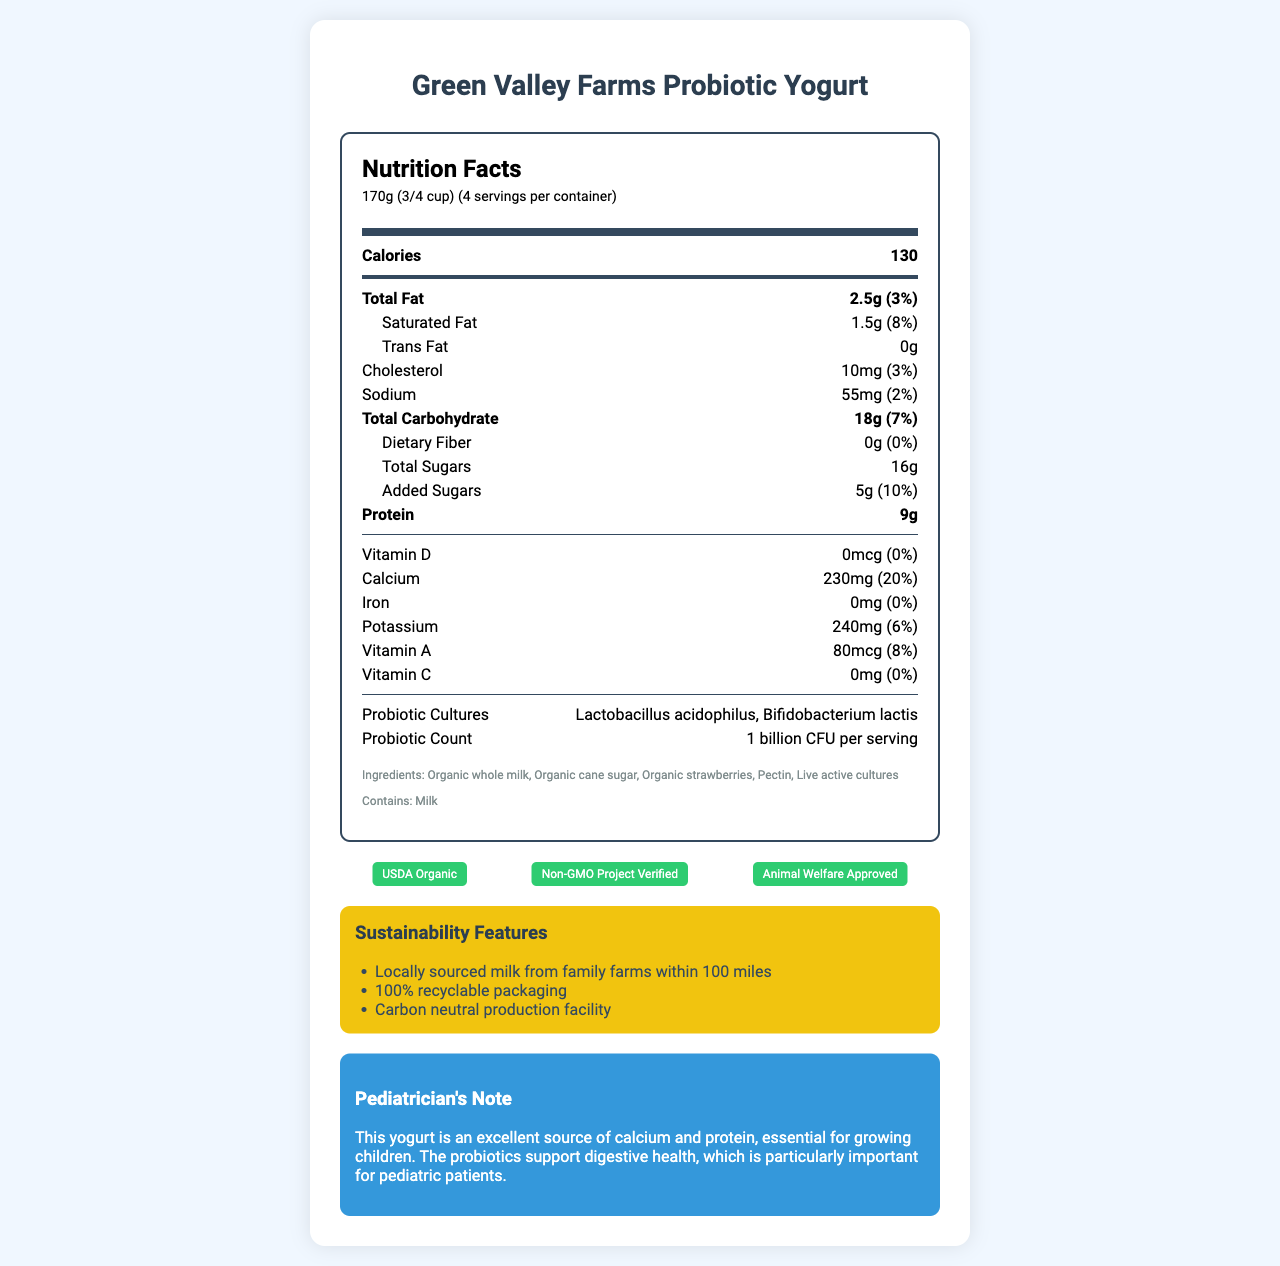who produces the yogurt? The product name mentioned at the beginning of the document is "Green Valley Farms Probiotic Yogurt," indicating the producer is Green Valley Farms.
Answer: Green Valley Farms what is the serving size for the yogurt? The document specifies the serving size as "170g (3/4 cup)" near the top under the heading "Nutrition Facts."
Answer: 170g (3/4 cup) how many servings are there per container? The document states there are "4 servings per container" in the serving information section.
Answer: 4 how many calories are in one serving? The calories per serving are listed as "130" in the bold calories section.
Answer: 130 what percentage of the daily value of calcium does this yogurt provide? The daily value for calcium is stated to be "20%" in the nutritional information section.
Answer: 20% what type of milk is used in this yogurt? The ingredients list includes "Organic whole milk" as one of the components.
Answer: Organic whole milk which probiotic cultures are present in the yogurt? A. Lactobacillus acidophilus B. Bifidobacterium longum C. Lactobacillus acidophilus and Bifidobacterium lactis D. Lactobacillus rhamnosus The document lists "Lactobacillus acidophilus, Bifidobacterium lactis" under probiotic cultures.
Answer: C what is the total fat content per serving? The total fat content is listed as "2.5g" in the nutrition information section.
Answer: 2.5g is this product non-GMO? The certifications section shows that the yogurt is "Non-GMO Project Verified," indicating it is non-GMO.
Answer: Yes how many grams of protein are in one serving? The nutritional information lists the protein content as "9g."
Answer: 9g how much added sugar is in one serving? The amount of added sugars per serving is "5g" as mentioned in the sub-item under total sugars.
Answer: 5g what is the percentage of daily value for sodium? The daily value for sodium is "2%" as listed in the nutritional information section.
Answer: 2% which certification indicates that animal welfare standards are met? A. USDA Organic B. Non-GMO Project Verified C. Animal Welfare Approved D. Whole30 Approved The document lists "Animal Welfare Approved" under the certifications, indicating animal welfare standards are met.
Answer: C does this yogurt contain any dietary fiber? The document states "Dietary Fiber: 0g (0%)" indicating it contains no dietary fiber.
Answer: No describe the sustainability features of this yogurt. The sustainability section describes that the product uses locally sourced milk, has fully recyclable packaging, and is produced in a carbon-neutral facility.
Answer: The yogurt features milk sourced locally from family farms within 100 miles, 100% recyclable packaging, and is produced in a carbon-neutral facility. how many billion CFU of probiotics are present per serving? The document lists the probiotic count as "1 billion CFU per serving" in the nutritional information section.
Answer: 1 billion what is the primary allergen listed for this yogurt? The allergens section states "Contains: Milk," indicating milk as the primary allergen.
Answer: Milk what is the daily value percentage for vitamin D in this yogurt? The document lists the daily value for vitamin D as "0%" in the nutritional information section.
Answer: 0% how much sugar does this yogurt contain in total? The document states that the yogurt contains "16g" of total sugars.
Answer: 16g are any artificial flavors mentioned in the ingredients list? The ingredients list does not mention any artificial flavors, and all listed ingredients are organic and natural components.
Answer: No what is the pediatrician's note about this yogurt? The pediatrician's note provided in the document highlights the yogurt as a good source of calcium and protein and mentions the importance of probiotics for digestive health in children.
Answer: This yogurt is an excellent source of calcium and protein, essential for growing children. The probiotics support digestive health, which is particularly important for pediatric patients. how are the nutrition facts visually divided in the document? The nutrition facts section is organized with bold headers for each main nutrient, sub-items for related details, and divider lines to separate different sections and nutrients.
Answer: The facts are divided by bold headers, sub-items, and divider lines 